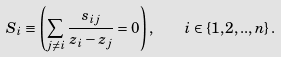<formula> <loc_0><loc_0><loc_500><loc_500>S _ { i } \equiv \left ( \sum _ { j \neq i } \frac { s _ { i j } } { z _ { i } - z _ { j } } = 0 \right ) , \quad i \in \{ 1 , 2 , . . , n \} \, .</formula> 